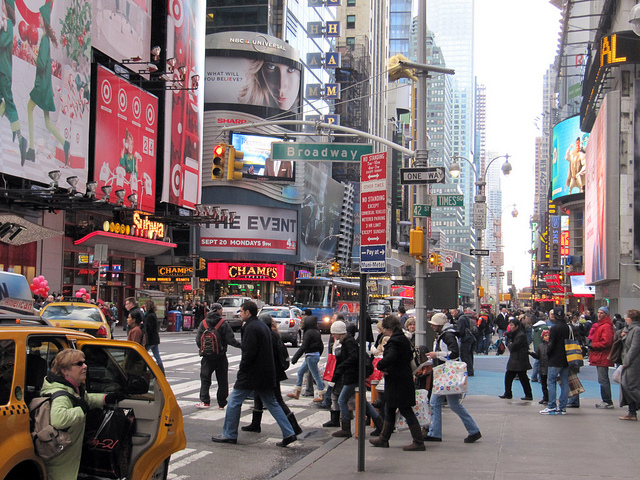Identify the text displayed in this image. THE EVENT MONDAYS H M A YOU universal AL 42 TIMES WAY ONE Broadway CHAMPS CHAMPS SHARP 